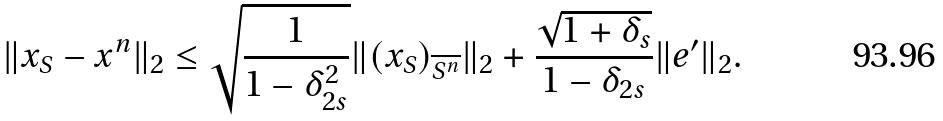Convert formula to latex. <formula><loc_0><loc_0><loc_500><loc_500>& \| x _ { S } - x ^ { n } \| _ { 2 } \leq \sqrt { \frac { 1 } { 1 - \delta _ { 2 s } ^ { 2 } } } \| ( x _ { S } ) _ { \overline { S ^ { n } } } \| _ { 2 } + \frac { \sqrt { 1 + \delta _ { s } } } { 1 - \delta _ { 2 s } } \| e ^ { \prime } \| _ { 2 } .</formula> 